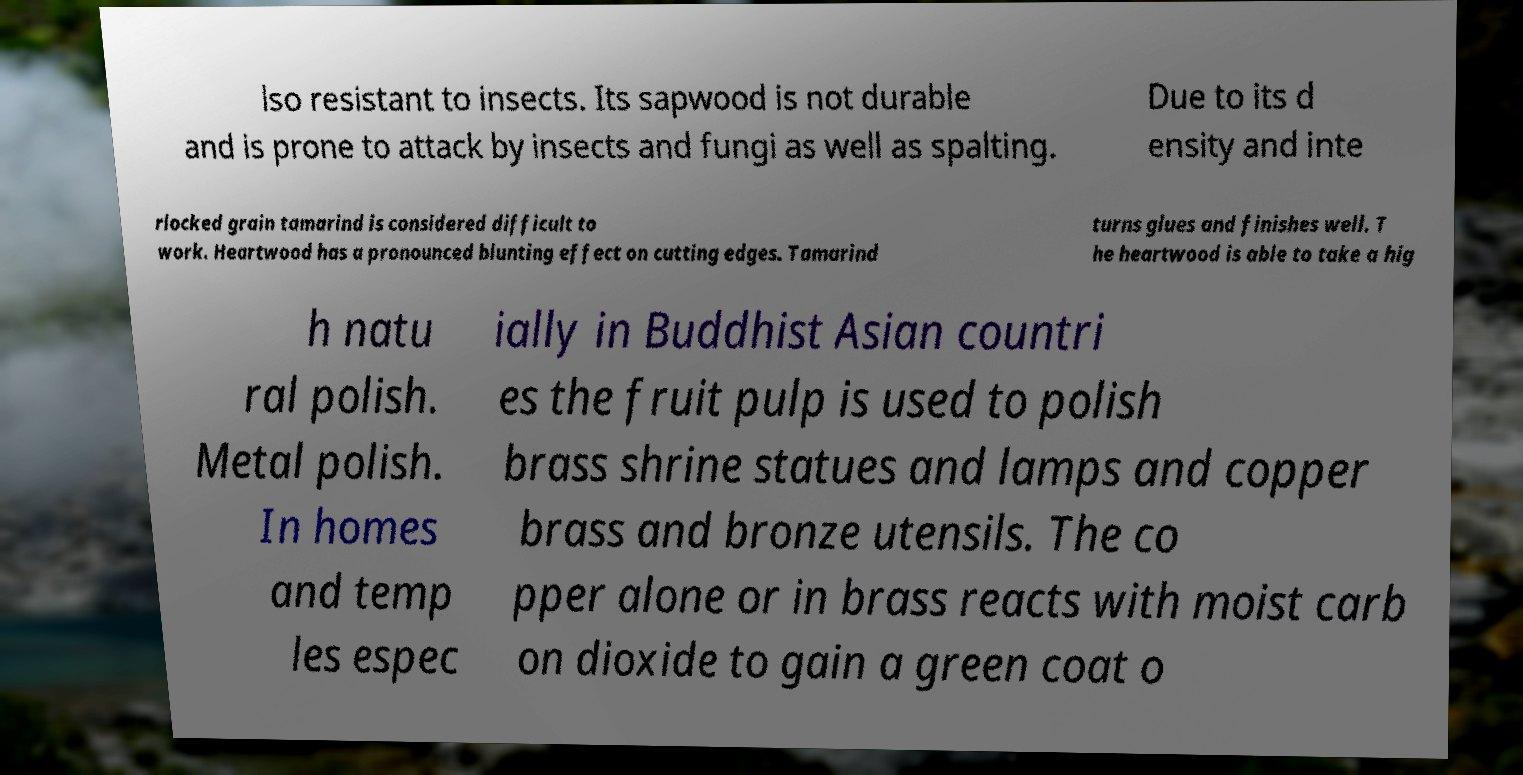There's text embedded in this image that I need extracted. Can you transcribe it verbatim? lso resistant to insects. Its sapwood is not durable and is prone to attack by insects and fungi as well as spalting. Due to its d ensity and inte rlocked grain tamarind is considered difficult to work. Heartwood has a pronounced blunting effect on cutting edges. Tamarind turns glues and finishes well. T he heartwood is able to take a hig h natu ral polish. Metal polish. In homes and temp les espec ially in Buddhist Asian countri es the fruit pulp is used to polish brass shrine statues and lamps and copper brass and bronze utensils. The co pper alone or in brass reacts with moist carb on dioxide to gain a green coat o 